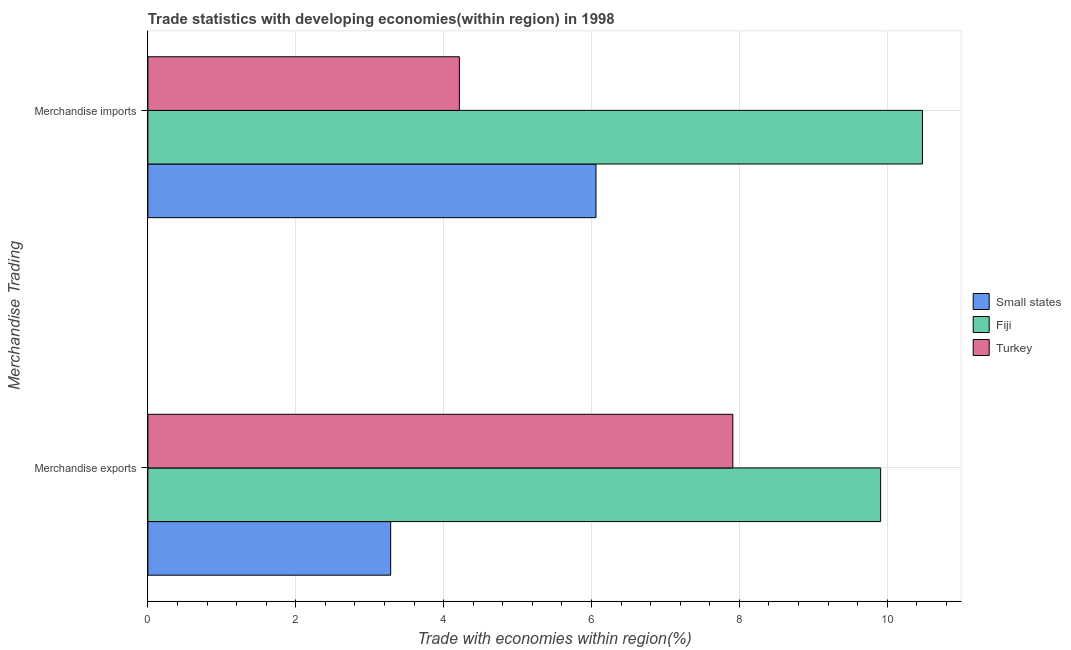How many different coloured bars are there?
Provide a short and direct response. 3. Are the number of bars on each tick of the Y-axis equal?
Your response must be concise. Yes. How many bars are there on the 1st tick from the bottom?
Make the answer very short. 3. What is the label of the 2nd group of bars from the top?
Ensure brevity in your answer.  Merchandise exports. What is the merchandise imports in Turkey?
Make the answer very short. 4.21. Across all countries, what is the maximum merchandise exports?
Make the answer very short. 9.91. Across all countries, what is the minimum merchandise imports?
Make the answer very short. 4.21. In which country was the merchandise imports maximum?
Ensure brevity in your answer.  Fiji. In which country was the merchandise exports minimum?
Provide a succinct answer. Small states. What is the total merchandise exports in the graph?
Provide a succinct answer. 21.11. What is the difference between the merchandise imports in Turkey and that in Fiji?
Ensure brevity in your answer.  -6.26. What is the difference between the merchandise exports in Fiji and the merchandise imports in Small states?
Your answer should be very brief. 3.85. What is the average merchandise exports per country?
Provide a succinct answer. 7.04. What is the difference between the merchandise exports and merchandise imports in Small states?
Keep it short and to the point. -2.78. In how many countries, is the merchandise imports greater than 3.2 %?
Your response must be concise. 3. What is the ratio of the merchandise exports in Turkey to that in Small states?
Provide a succinct answer. 2.41. In how many countries, is the merchandise exports greater than the average merchandise exports taken over all countries?
Offer a terse response. 2. What does the 3rd bar from the top in Merchandise imports represents?
Your response must be concise. Small states. What does the 1st bar from the bottom in Merchandise exports represents?
Offer a terse response. Small states. How many bars are there?
Offer a terse response. 6. Are all the bars in the graph horizontal?
Keep it short and to the point. Yes. How many countries are there in the graph?
Offer a very short reply. 3. What is the difference between two consecutive major ticks on the X-axis?
Offer a terse response. 2. Are the values on the major ticks of X-axis written in scientific E-notation?
Provide a short and direct response. No. How many legend labels are there?
Make the answer very short. 3. What is the title of the graph?
Provide a short and direct response. Trade statistics with developing economies(within region) in 1998. What is the label or title of the X-axis?
Offer a very short reply. Trade with economies within region(%). What is the label or title of the Y-axis?
Offer a very short reply. Merchandise Trading. What is the Trade with economies within region(%) in Small states in Merchandise exports?
Provide a succinct answer. 3.28. What is the Trade with economies within region(%) in Fiji in Merchandise exports?
Provide a short and direct response. 9.91. What is the Trade with economies within region(%) in Turkey in Merchandise exports?
Keep it short and to the point. 7.91. What is the Trade with economies within region(%) in Small states in Merchandise imports?
Keep it short and to the point. 6.06. What is the Trade with economies within region(%) of Fiji in Merchandise imports?
Your answer should be compact. 10.48. What is the Trade with economies within region(%) of Turkey in Merchandise imports?
Offer a very short reply. 4.21. Across all Merchandise Trading, what is the maximum Trade with economies within region(%) in Small states?
Ensure brevity in your answer.  6.06. Across all Merchandise Trading, what is the maximum Trade with economies within region(%) of Fiji?
Give a very brief answer. 10.48. Across all Merchandise Trading, what is the maximum Trade with economies within region(%) in Turkey?
Offer a terse response. 7.91. Across all Merchandise Trading, what is the minimum Trade with economies within region(%) of Small states?
Provide a succinct answer. 3.28. Across all Merchandise Trading, what is the minimum Trade with economies within region(%) of Fiji?
Make the answer very short. 9.91. Across all Merchandise Trading, what is the minimum Trade with economies within region(%) of Turkey?
Keep it short and to the point. 4.21. What is the total Trade with economies within region(%) in Small states in the graph?
Keep it short and to the point. 9.34. What is the total Trade with economies within region(%) in Fiji in the graph?
Your answer should be compact. 20.39. What is the total Trade with economies within region(%) of Turkey in the graph?
Offer a very short reply. 12.13. What is the difference between the Trade with economies within region(%) in Small states in Merchandise exports and that in Merchandise imports?
Offer a terse response. -2.78. What is the difference between the Trade with economies within region(%) of Fiji in Merchandise exports and that in Merchandise imports?
Your answer should be very brief. -0.57. What is the difference between the Trade with economies within region(%) of Turkey in Merchandise exports and that in Merchandise imports?
Provide a short and direct response. 3.7. What is the difference between the Trade with economies within region(%) in Small states in Merchandise exports and the Trade with economies within region(%) in Fiji in Merchandise imports?
Provide a short and direct response. -7.19. What is the difference between the Trade with economies within region(%) of Small states in Merchandise exports and the Trade with economies within region(%) of Turkey in Merchandise imports?
Make the answer very short. -0.93. What is the difference between the Trade with economies within region(%) in Fiji in Merchandise exports and the Trade with economies within region(%) in Turkey in Merchandise imports?
Provide a succinct answer. 5.7. What is the average Trade with economies within region(%) in Small states per Merchandise Trading?
Offer a terse response. 4.67. What is the average Trade with economies within region(%) of Fiji per Merchandise Trading?
Offer a terse response. 10.19. What is the average Trade with economies within region(%) of Turkey per Merchandise Trading?
Give a very brief answer. 6.06. What is the difference between the Trade with economies within region(%) of Small states and Trade with economies within region(%) of Fiji in Merchandise exports?
Your response must be concise. -6.63. What is the difference between the Trade with economies within region(%) in Small states and Trade with economies within region(%) in Turkey in Merchandise exports?
Offer a terse response. -4.63. What is the difference between the Trade with economies within region(%) in Fiji and Trade with economies within region(%) in Turkey in Merchandise exports?
Your response must be concise. 2. What is the difference between the Trade with economies within region(%) of Small states and Trade with economies within region(%) of Fiji in Merchandise imports?
Offer a terse response. -4.42. What is the difference between the Trade with economies within region(%) in Small states and Trade with economies within region(%) in Turkey in Merchandise imports?
Make the answer very short. 1.85. What is the difference between the Trade with economies within region(%) of Fiji and Trade with economies within region(%) of Turkey in Merchandise imports?
Offer a very short reply. 6.26. What is the ratio of the Trade with economies within region(%) in Small states in Merchandise exports to that in Merchandise imports?
Provide a succinct answer. 0.54. What is the ratio of the Trade with economies within region(%) in Fiji in Merchandise exports to that in Merchandise imports?
Offer a very short reply. 0.95. What is the ratio of the Trade with economies within region(%) in Turkey in Merchandise exports to that in Merchandise imports?
Your answer should be very brief. 1.88. What is the difference between the highest and the second highest Trade with economies within region(%) of Small states?
Ensure brevity in your answer.  2.78. What is the difference between the highest and the second highest Trade with economies within region(%) of Fiji?
Ensure brevity in your answer.  0.57. What is the difference between the highest and the second highest Trade with economies within region(%) of Turkey?
Your answer should be compact. 3.7. What is the difference between the highest and the lowest Trade with economies within region(%) in Small states?
Ensure brevity in your answer.  2.78. What is the difference between the highest and the lowest Trade with economies within region(%) in Fiji?
Offer a very short reply. 0.57. What is the difference between the highest and the lowest Trade with economies within region(%) in Turkey?
Make the answer very short. 3.7. 